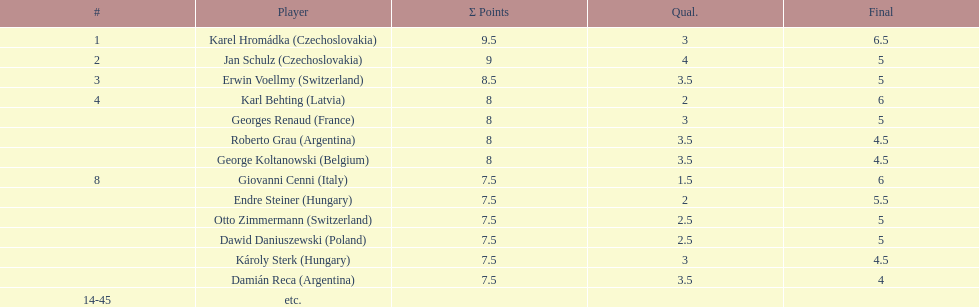How many countries had at least two players competing in the consolation cup? 4. 